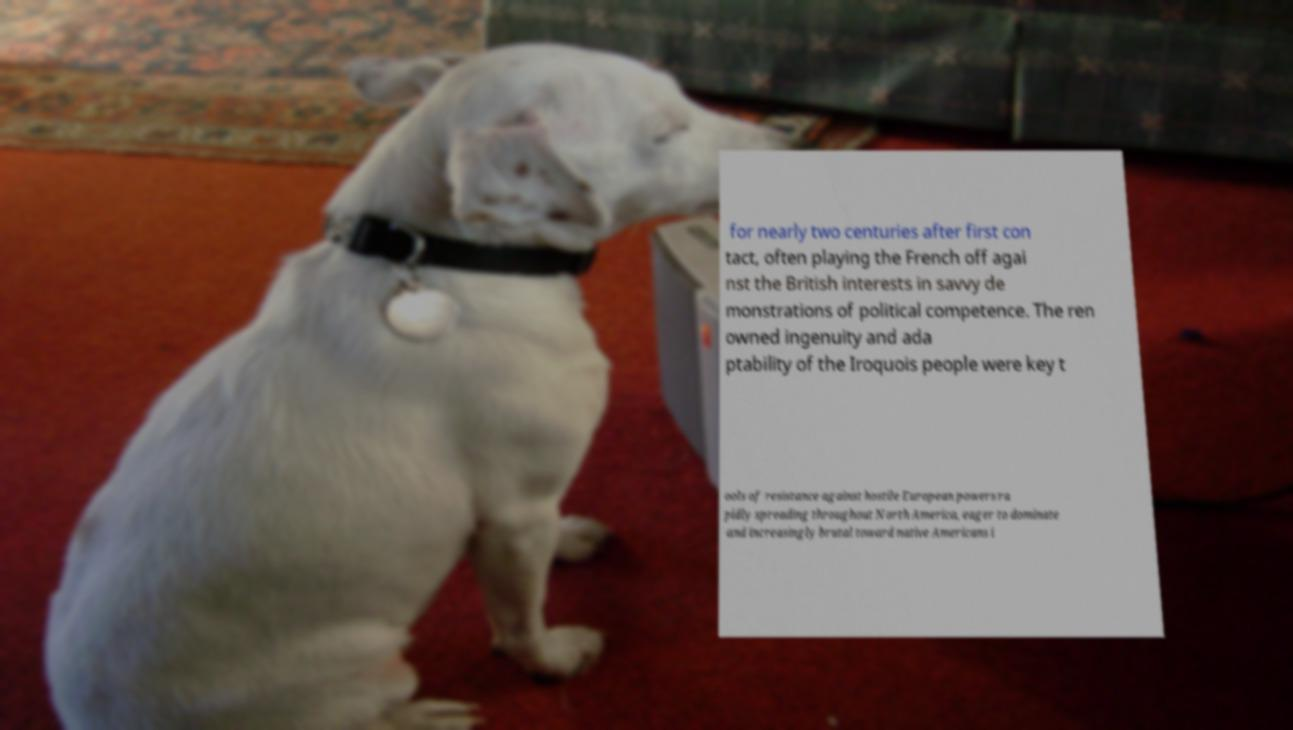Please identify and transcribe the text found in this image. for nearly two centuries after first con tact, often playing the French off agai nst the British interests in savvy de monstrations of political competence. The ren owned ingenuity and ada ptability of the Iroquois people were key t ools of resistance against hostile European powers ra pidly spreading throughout North America, eager to dominate and increasingly brutal toward native Americans i 